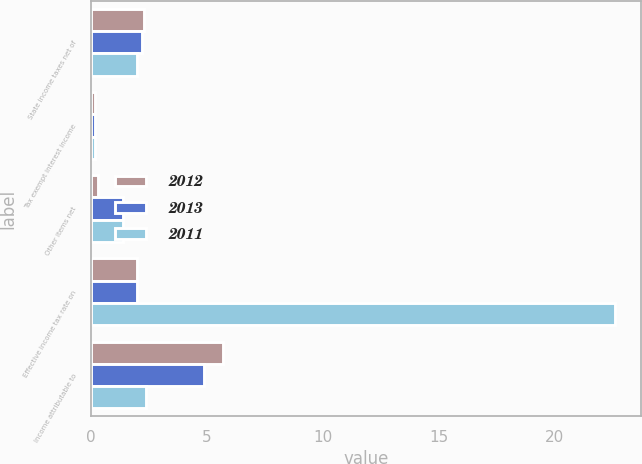Convert chart to OTSL. <chart><loc_0><loc_0><loc_500><loc_500><stacked_bar_chart><ecel><fcel>State income taxes net of<fcel>Tax exempt interest income<fcel>Other items net<fcel>Effective income tax rate on<fcel>Income attributable to<nl><fcel>2012<fcel>2.3<fcel>0.2<fcel>0.3<fcel>2<fcel>5.7<nl><fcel>2013<fcel>2.2<fcel>0.2<fcel>1.4<fcel>2<fcel>4.9<nl><fcel>2011<fcel>2<fcel>0.2<fcel>1.4<fcel>22.6<fcel>2.4<nl></chart> 